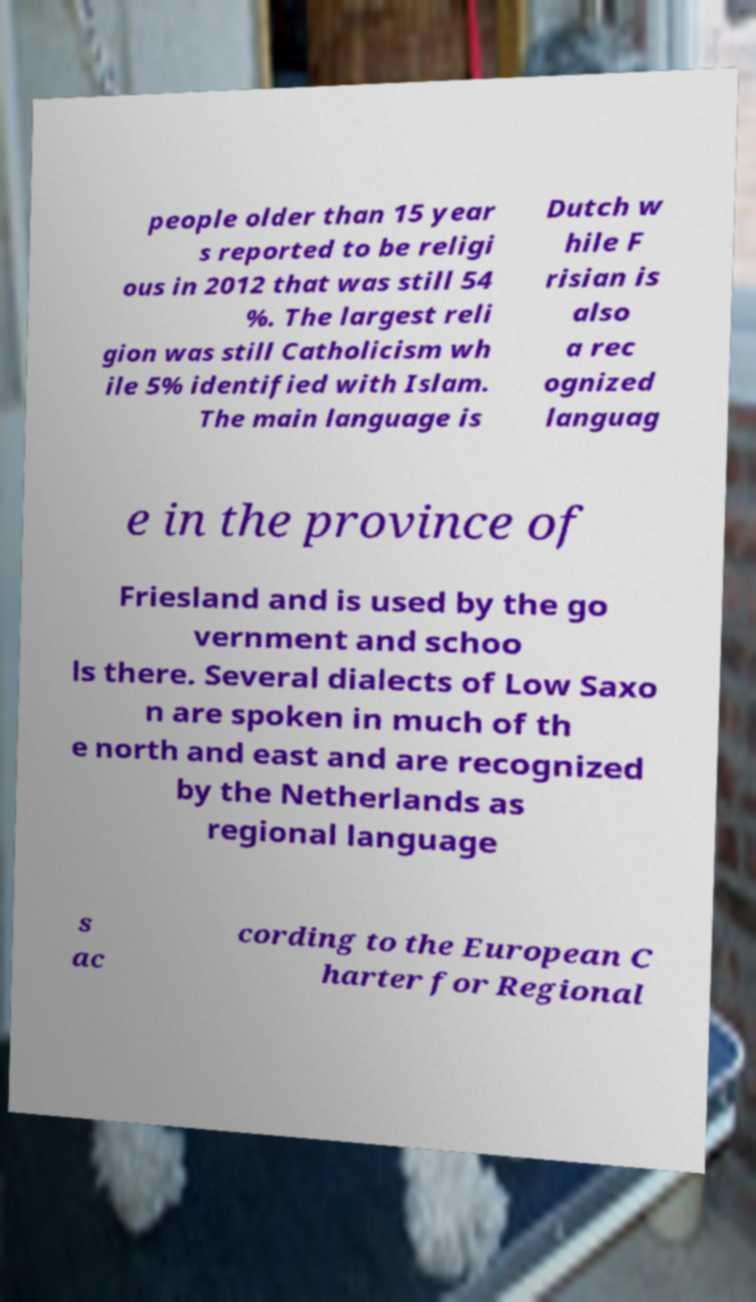Can you accurately transcribe the text from the provided image for me? people older than 15 year s reported to be religi ous in 2012 that was still 54 %. The largest reli gion was still Catholicism wh ile 5% identified with Islam. The main language is Dutch w hile F risian is also a rec ognized languag e in the province of Friesland and is used by the go vernment and schoo ls there. Several dialects of Low Saxo n are spoken in much of th e north and east and are recognized by the Netherlands as regional language s ac cording to the European C harter for Regional 